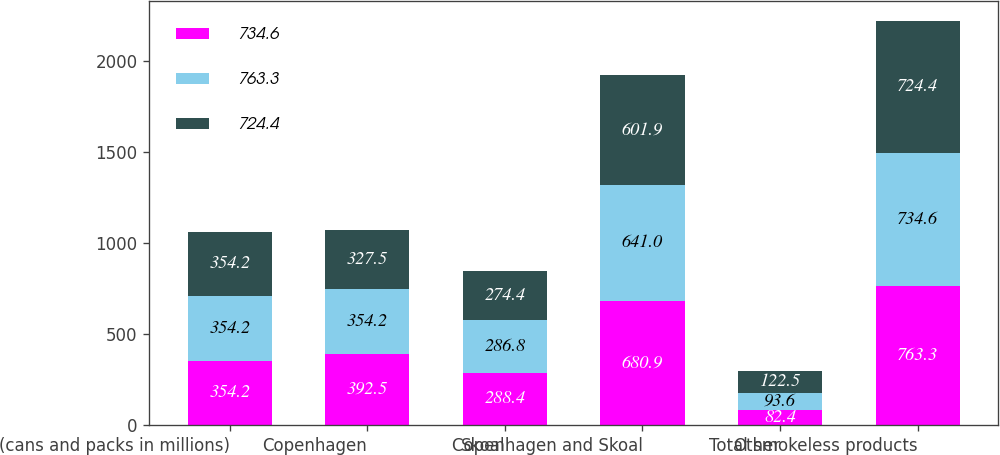Convert chart. <chart><loc_0><loc_0><loc_500><loc_500><stacked_bar_chart><ecel><fcel>(cans and packs in millions)<fcel>Copenhagen<fcel>Skoal<fcel>Copenhagen and Skoal<fcel>Other<fcel>Total smokeless products<nl><fcel>734.6<fcel>354.2<fcel>392.5<fcel>288.4<fcel>680.9<fcel>82.4<fcel>763.3<nl><fcel>763.3<fcel>354.2<fcel>354.2<fcel>286.8<fcel>641<fcel>93.6<fcel>734.6<nl><fcel>724.4<fcel>354.2<fcel>327.5<fcel>274.4<fcel>601.9<fcel>122.5<fcel>724.4<nl></chart> 